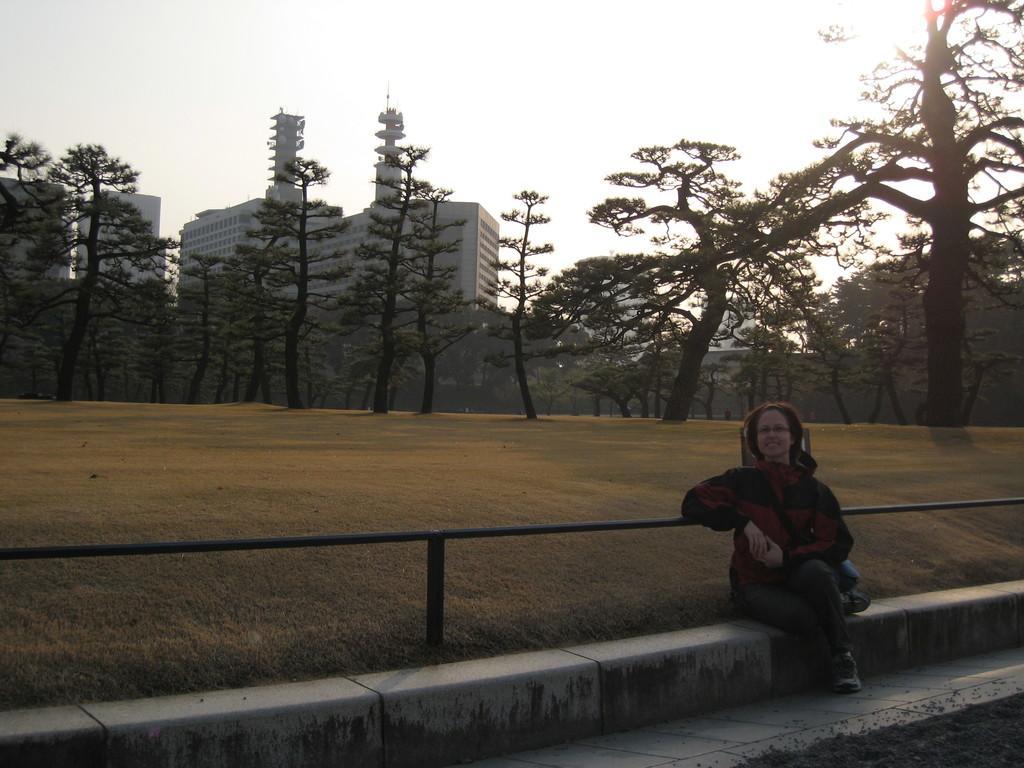Could you give a brief overview of what you see in this image? As we can see in the image in the front there is a woman sitting in the front. In the background there are trees and buildings. On the top there is sky. 